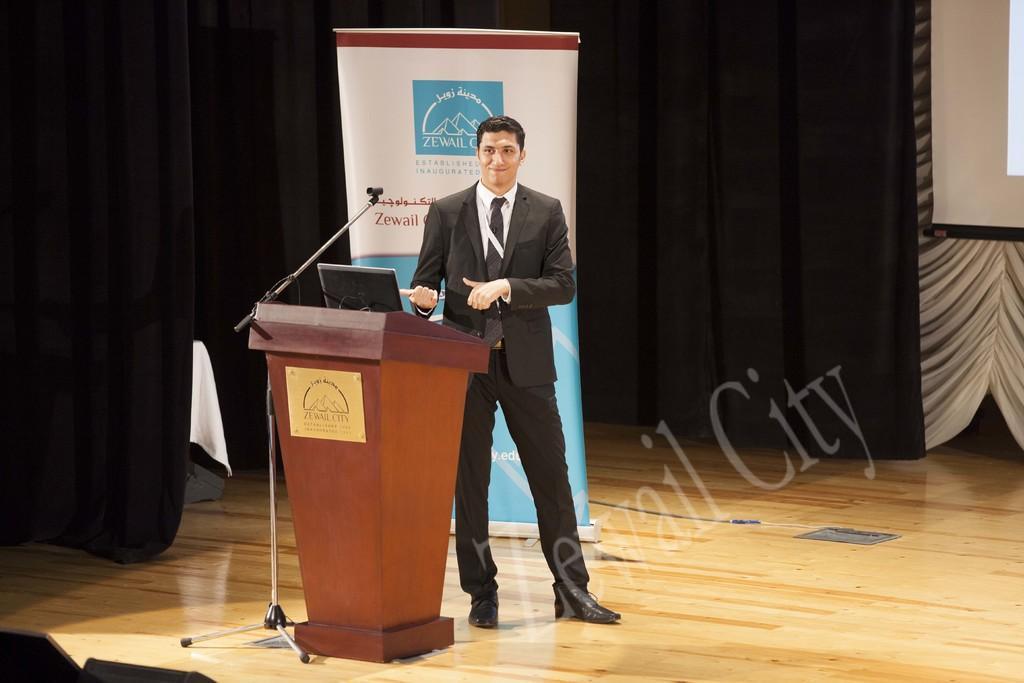In one or two sentences, can you explain what this image depicts? In the center of the image there is a person wearing suit and standing near a podium. There is a laptop on the podium. There is a mic stand. In the background of the image there is black color curtain. There is a banner. At the bottom of the image there is wooden flooring. 